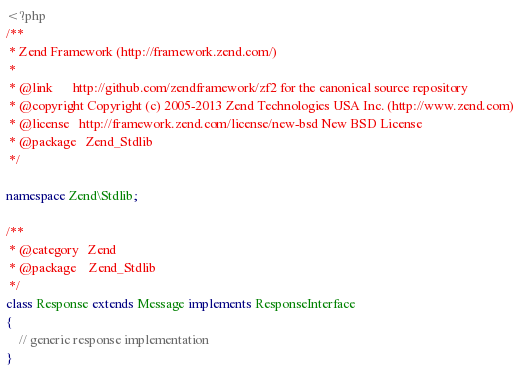Convert code to text. <code><loc_0><loc_0><loc_500><loc_500><_PHP_><?php
/**
 * Zend Framework (http://framework.zend.com/)
 *
 * @link      http://github.com/zendframework/zf2 for the canonical source repository
 * @copyright Copyright (c) 2005-2013 Zend Technologies USA Inc. (http://www.zend.com)
 * @license   http://framework.zend.com/license/new-bsd New BSD License
 * @package   Zend_Stdlib
 */

namespace Zend\Stdlib;

/**
 * @category   Zend
 * @package    Zend_Stdlib
 */
class Response extends Message implements ResponseInterface
{
    // generic response implementation
}
</code> 